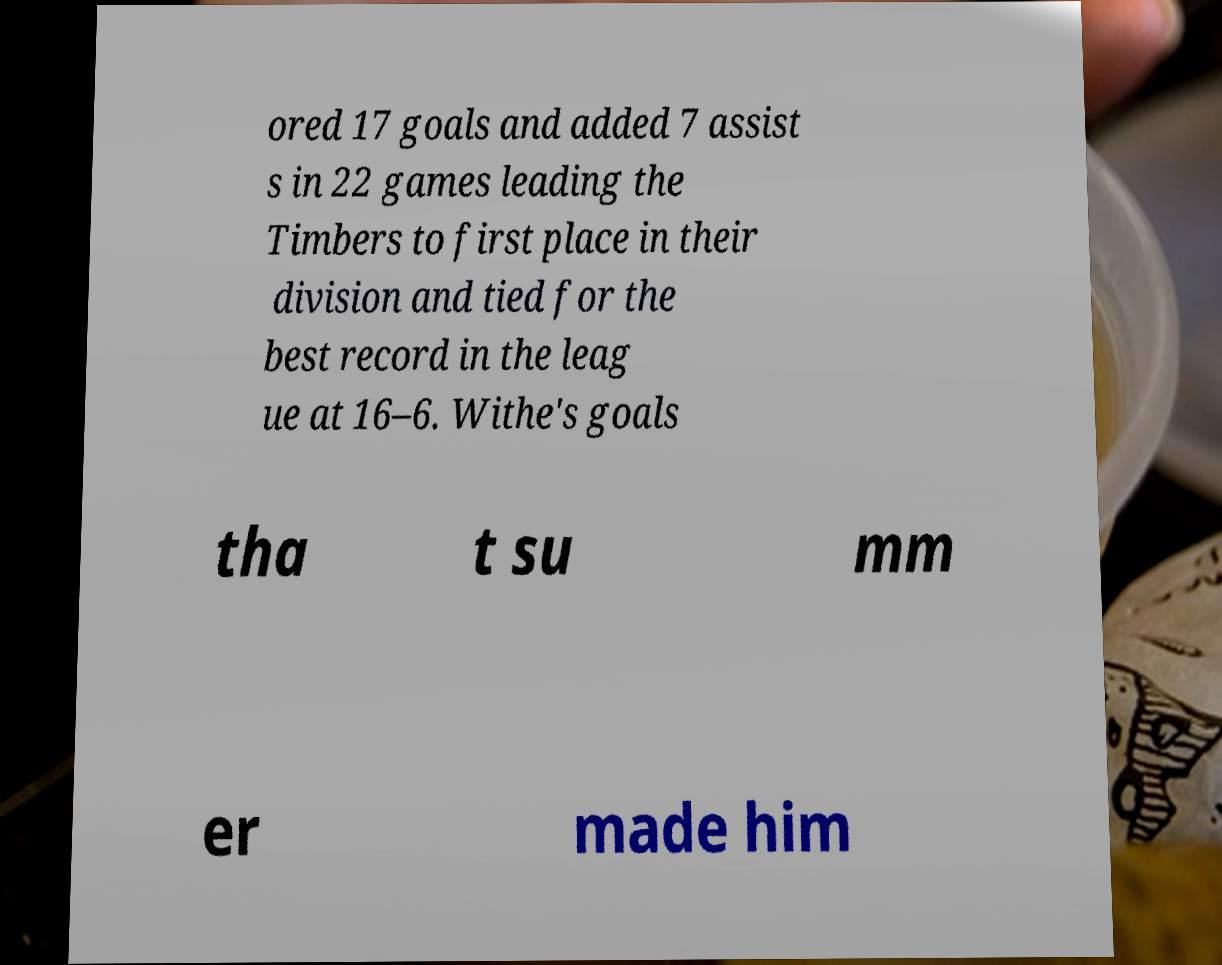Could you extract and type out the text from this image? ored 17 goals and added 7 assist s in 22 games leading the Timbers to first place in their division and tied for the best record in the leag ue at 16–6. Withe's goals tha t su mm er made him 